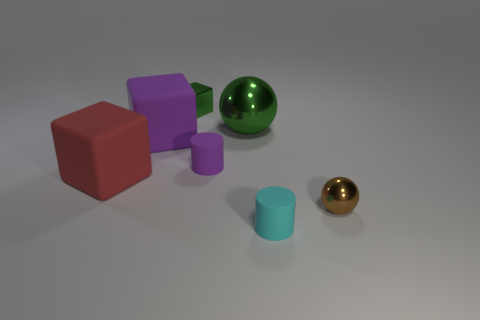What number of other things are the same color as the small cube?
Provide a succinct answer. 1. What number of things are both on the right side of the purple matte cylinder and behind the cyan matte object?
Provide a succinct answer. 2. What shape is the big purple object?
Your answer should be very brief. Cube. What number of other objects are the same material as the small purple cylinder?
Provide a succinct answer. 3. The cube that is behind the purple thing that is on the left side of the small rubber object behind the cyan rubber cylinder is what color?
Offer a very short reply. Green. There is a purple thing that is the same size as the red rubber thing; what material is it?
Provide a short and direct response. Rubber. What number of things are either tiny rubber things that are on the left side of the small cyan rubber object or small purple objects?
Offer a terse response. 1. Is there a cyan cylinder?
Offer a very short reply. Yes. What is the tiny thing in front of the brown thing made of?
Ensure brevity in your answer.  Rubber. What material is the block that is the same color as the large sphere?
Your answer should be very brief. Metal. 